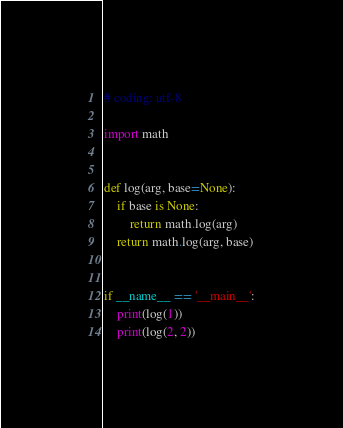Convert code to text. <code><loc_0><loc_0><loc_500><loc_500><_Python_># coding: utf-8

import math


def log(arg, base=None):
    if base is None:
        return math.log(arg)
    return math.log(arg, base)


if __name__ == '__main__':
    print(log(1))
    print(log(2, 2))
</code> 